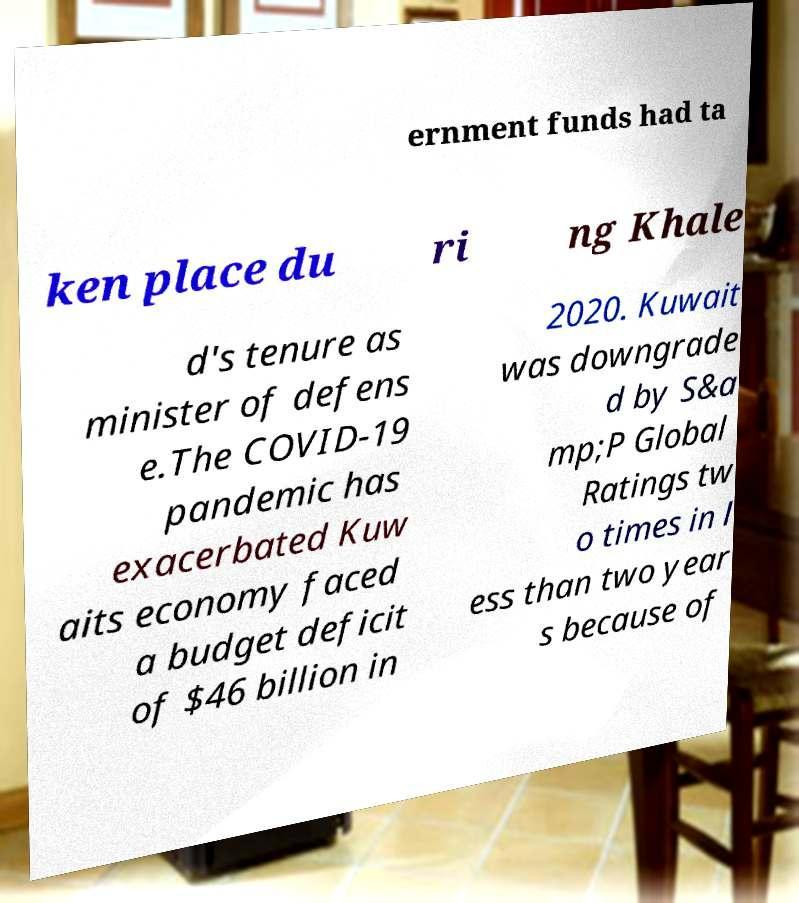Please read and relay the text visible in this image. What does it say? ernment funds had ta ken place du ri ng Khale d's tenure as minister of defens e.The COVID-19 pandemic has exacerbated Kuw aits economy faced a budget deficit of $46 billion in 2020. Kuwait was downgrade d by S&a mp;P Global Ratings tw o times in l ess than two year s because of 